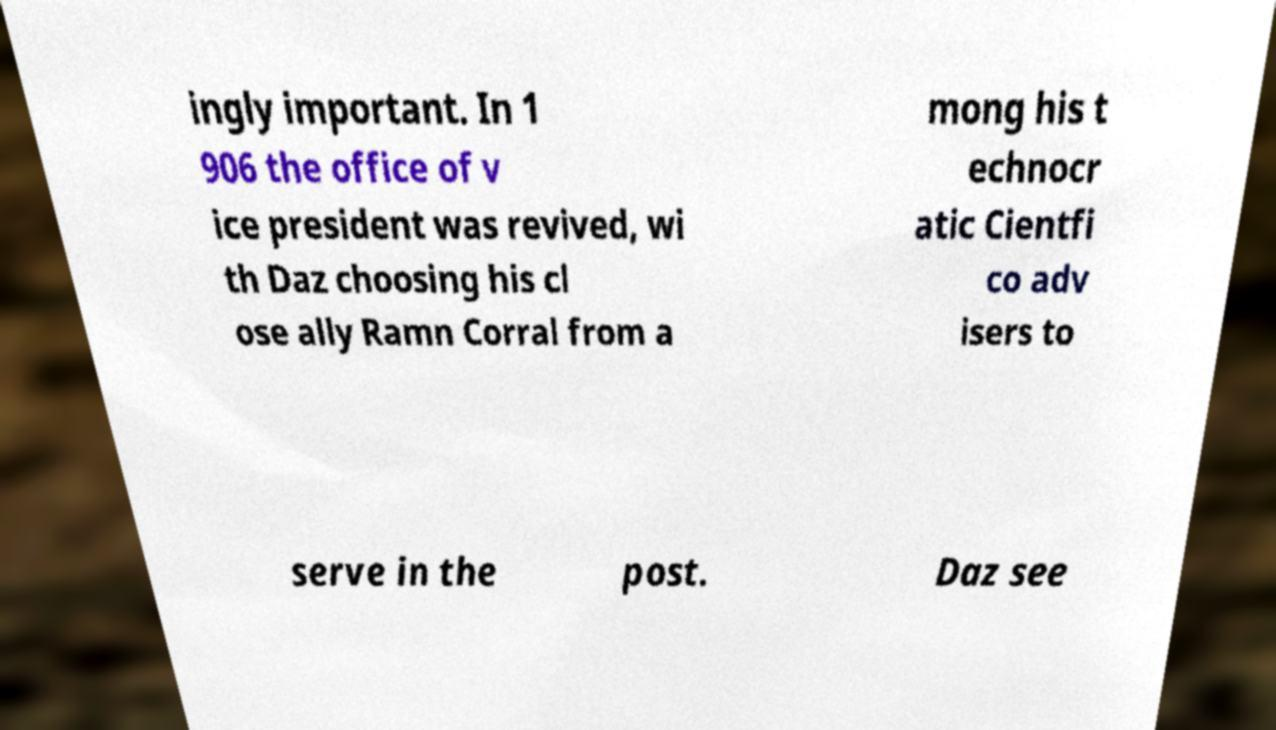Can you read and provide the text displayed in the image?This photo seems to have some interesting text. Can you extract and type it out for me? ingly important. In 1 906 the office of v ice president was revived, wi th Daz choosing his cl ose ally Ramn Corral from a mong his t echnocr atic Cientfi co adv isers to serve in the post. Daz see 